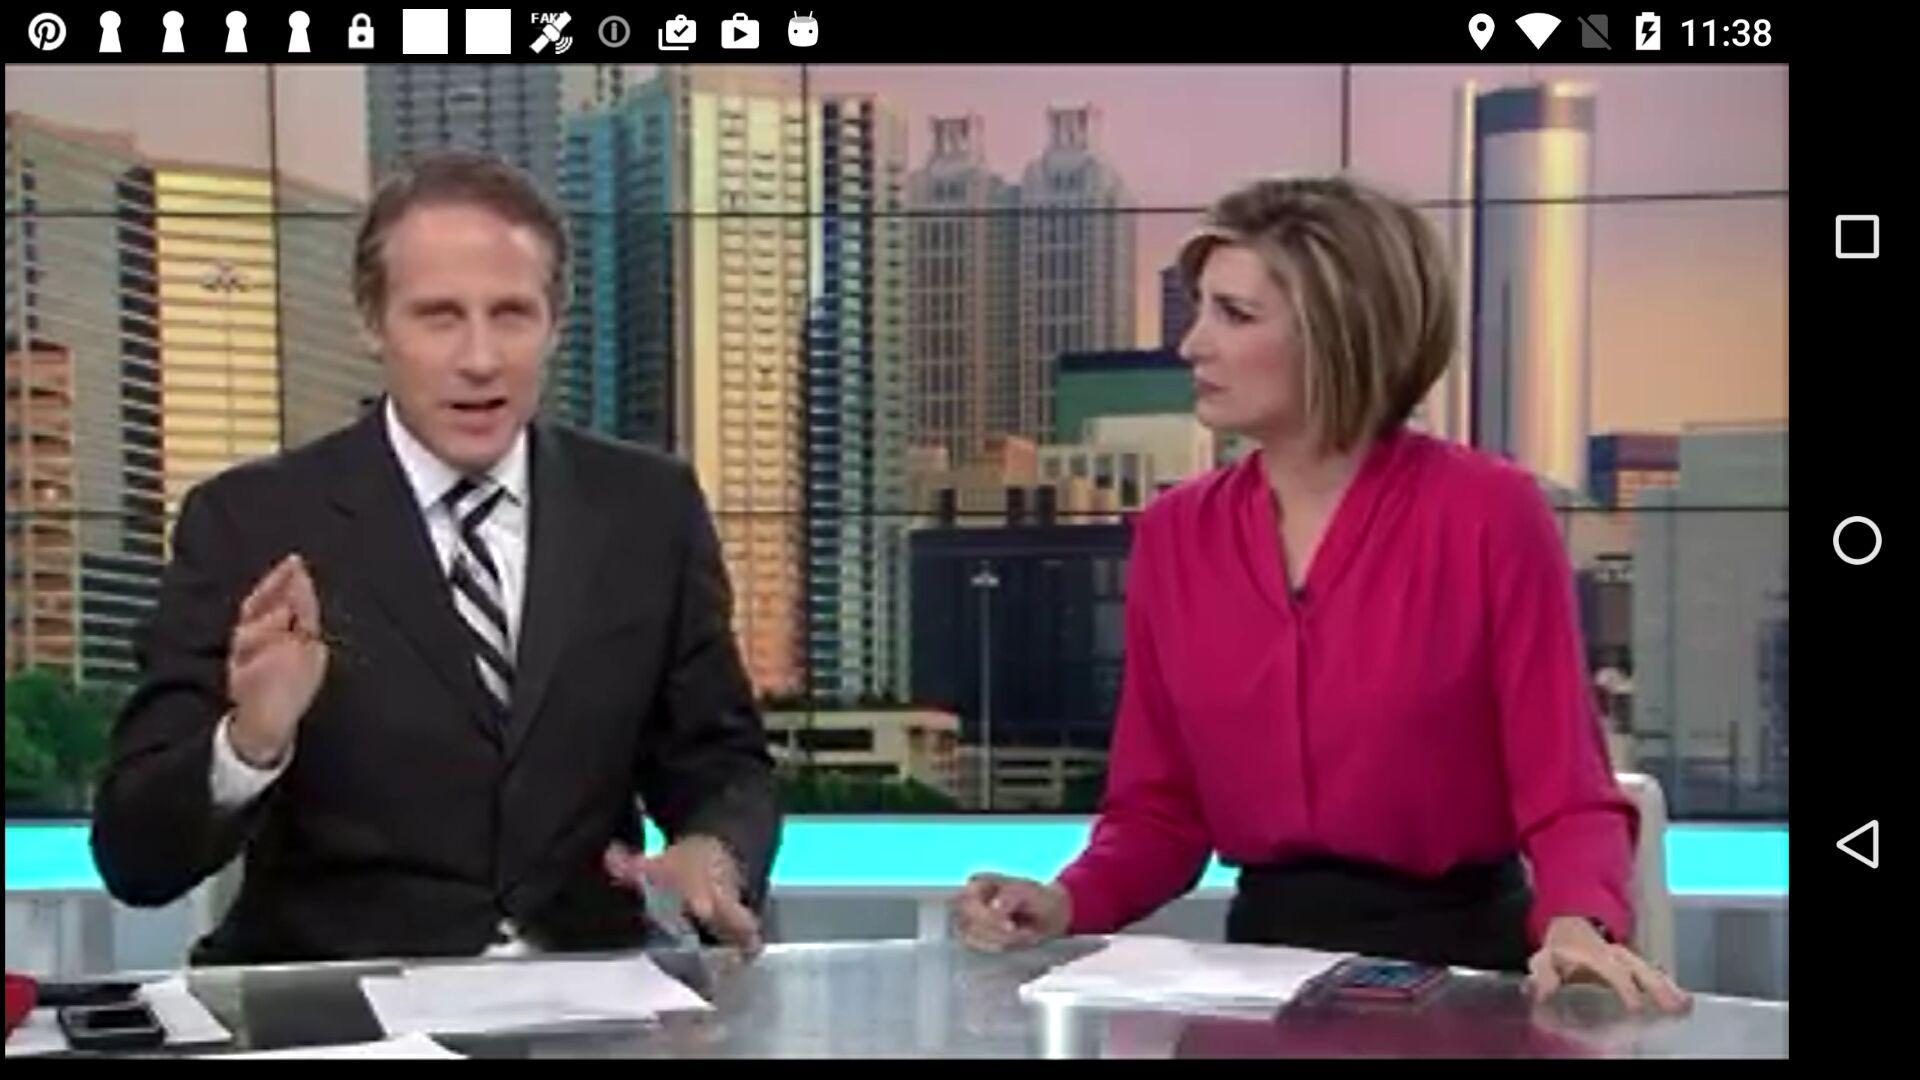What percent of District 6 voters do not like Trump? The percentage of District 6 voters who dislike Trump is 47%. 